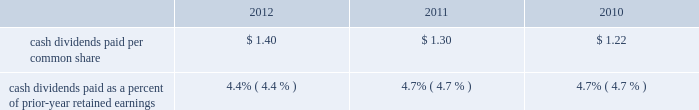And machine tooling to enhance manufacturing operations , and ongoing replacements of manufacturing and distribution equipment .
Capital spending in all three years also included spending for the replacement and enhancement of the company 2019s global enterprise resource planning ( erp ) management information systems , as well as spending to enhance the company 2019s corporate headquarters and research and development facilities in kenosha , wisconsin .
Snap-on believes that its cash generated from operations , as well as its available cash on hand and funds available from its credit facilities will be sufficient to fund the company 2019s capital expenditure requirements in 2013 .
In 2010 , snap-on acquired the remaining 40% ( 40 % ) interest in snap-on asia manufacturing ( zhejiang ) co. , ltd. , the company 2019s tool manufacturing operation in xiaoshan , china , for a purchase price of $ 7.7 million and $ 0.1 million of transaction costs ; snap-on acquired the initial 60% ( 60 % ) interest in 2008 .
See note 2 to the consolidated financial statements for additional information .
Financing activities net cash used by financing activities was $ 127.0 million in 2012 .
Net cash used by financing activities of $ 293.7 million in 2011 included the august 2011 repayment of $ 200 million of unsecured 6.25% ( 6.25 % ) notes upon maturity with available cash .
In december 2010 , snap-on sold $ 250 million of unsecured 4.25% ( 4.25 % ) long-term notes at a discount ; snap-on is using , and has used , the $ 247.7 million of proceeds from the sale of these notes , net of $ 1.6 million of transaction costs , for general corporate purposes , which included working capital , capital expenditures , repayment of all or a portion of the company 2019s $ 200 million , 6.25% ( 6.25 % ) unsecured notes that matured in august 2011 , and the financing of finance and contract receivables , primarily related to soc .
In january 2010 , snap-on repaid $ 150 million of unsecured floating rate debt upon maturity with available cash .
Proceeds from stock purchase and option plan exercises totaled $ 46.8 million in 2012 , $ 25.7 million in 2011 and $ 23.7 million in 2010 .
Snap-on has undertaken stock repurchases from time to time to offset dilution created by shares issued for employee and franchisee stock purchase plans , stock options and other corporate purposes .
In 2012 , snap-on repurchased 1180000 shares of its common stock for $ 78.1 million under its previously announced share repurchase programs .
As of 2012 year end , snap-on had remaining availability to repurchase up to an additional $ 180.9 million in common stock pursuant to its board of directors 2019 ( the 201cboard 201d ) authorizations .
The purchase of snap-on common stock is at the company 2019s discretion , subject to prevailing financial and market conditions .
Snap-on repurchased 628000 shares of its common stock for $ 37.4 million in 2011 ; snap-on repurchased 152000 shares of its common stock for $ 8.7 million in 2010 .
Snap-on believes that its cash generated from operations , available cash on hand , and funds available from its credit facilities , will be sufficient to fund the company 2019s share repurchases , if any , in 2013 .
Snap-on has paid consecutive quarterly cash dividends , without interruption or reduction , since 1939 .
Cash dividends paid in 2012 , 2011 and 2010 totaled $ 81.5 million , $ 76.7 million and $ 71.3 million , respectively .
On november 1 , 2012 , the company announced that its board increased the quarterly cash dividend by 11.8% ( 11.8 % ) to $ 0.38 per share ( $ 1.52 per share per year ) .
Quarterly dividends declared in 2012 were $ 0.38 per share in the fourth quarter and $ 0.34 per share in the first three quarters ( $ 1.40 per share for the year ) .
Quarterly dividends in 2011 were $ 0.34 per share in the fourth quarter and $ 0.32 per share in the first three quarters ( $ 1.30 per share for the year ) .
Quarterly dividends in 2010 were $ 0.32 per share in the fourth quarter and $ 0.30 per share in the first three quarters ( $ 1.22 per share for the year ) . .
Cash dividends paid as a percent of prior-year retained earnings 4.4% ( 4.4 % ) 4.7% ( 4.7 % ) snap-on believes that its cash generated from operations , available cash on hand and funds available from its credit facilities will be sufficient to pay dividends in 2013 .
Off-balance-sheet arrangements except as included below in the section labeled 201ccontractual obligations and commitments 201d and note 15 to the consolidated financial statements , the company had no off-balance-sheet arrangements as of 2012 year end .
2012 annual report 47 .
What is the average repurchase price per share in 2011? 
Computations: ((37.4 - 1000000) / 628000)
Answer: -1.5923. And machine tooling to enhance manufacturing operations , and ongoing replacements of manufacturing and distribution equipment .
Capital spending in all three years also included spending for the replacement and enhancement of the company 2019s global enterprise resource planning ( erp ) management information systems , as well as spending to enhance the company 2019s corporate headquarters and research and development facilities in kenosha , wisconsin .
Snap-on believes that its cash generated from operations , as well as its available cash on hand and funds available from its credit facilities will be sufficient to fund the company 2019s capital expenditure requirements in 2013 .
In 2010 , snap-on acquired the remaining 40% ( 40 % ) interest in snap-on asia manufacturing ( zhejiang ) co. , ltd. , the company 2019s tool manufacturing operation in xiaoshan , china , for a purchase price of $ 7.7 million and $ 0.1 million of transaction costs ; snap-on acquired the initial 60% ( 60 % ) interest in 2008 .
See note 2 to the consolidated financial statements for additional information .
Financing activities net cash used by financing activities was $ 127.0 million in 2012 .
Net cash used by financing activities of $ 293.7 million in 2011 included the august 2011 repayment of $ 200 million of unsecured 6.25% ( 6.25 % ) notes upon maturity with available cash .
In december 2010 , snap-on sold $ 250 million of unsecured 4.25% ( 4.25 % ) long-term notes at a discount ; snap-on is using , and has used , the $ 247.7 million of proceeds from the sale of these notes , net of $ 1.6 million of transaction costs , for general corporate purposes , which included working capital , capital expenditures , repayment of all or a portion of the company 2019s $ 200 million , 6.25% ( 6.25 % ) unsecured notes that matured in august 2011 , and the financing of finance and contract receivables , primarily related to soc .
In january 2010 , snap-on repaid $ 150 million of unsecured floating rate debt upon maturity with available cash .
Proceeds from stock purchase and option plan exercises totaled $ 46.8 million in 2012 , $ 25.7 million in 2011 and $ 23.7 million in 2010 .
Snap-on has undertaken stock repurchases from time to time to offset dilution created by shares issued for employee and franchisee stock purchase plans , stock options and other corporate purposes .
In 2012 , snap-on repurchased 1180000 shares of its common stock for $ 78.1 million under its previously announced share repurchase programs .
As of 2012 year end , snap-on had remaining availability to repurchase up to an additional $ 180.9 million in common stock pursuant to its board of directors 2019 ( the 201cboard 201d ) authorizations .
The purchase of snap-on common stock is at the company 2019s discretion , subject to prevailing financial and market conditions .
Snap-on repurchased 628000 shares of its common stock for $ 37.4 million in 2011 ; snap-on repurchased 152000 shares of its common stock for $ 8.7 million in 2010 .
Snap-on believes that its cash generated from operations , available cash on hand , and funds available from its credit facilities , will be sufficient to fund the company 2019s share repurchases , if any , in 2013 .
Snap-on has paid consecutive quarterly cash dividends , without interruption or reduction , since 1939 .
Cash dividends paid in 2012 , 2011 and 2010 totaled $ 81.5 million , $ 76.7 million and $ 71.3 million , respectively .
On november 1 , 2012 , the company announced that its board increased the quarterly cash dividend by 11.8% ( 11.8 % ) to $ 0.38 per share ( $ 1.52 per share per year ) .
Quarterly dividends declared in 2012 were $ 0.38 per share in the fourth quarter and $ 0.34 per share in the first three quarters ( $ 1.40 per share for the year ) .
Quarterly dividends in 2011 were $ 0.34 per share in the fourth quarter and $ 0.32 per share in the first three quarters ( $ 1.30 per share for the year ) .
Quarterly dividends in 2010 were $ 0.32 per share in the fourth quarter and $ 0.30 per share in the first three quarters ( $ 1.22 per share for the year ) . .
Cash dividends paid as a percent of prior-year retained earnings 4.4% ( 4.4 % ) 4.7% ( 4.7 % ) snap-on believes that its cash generated from operations , available cash on hand and funds available from its credit facilities will be sufficient to pay dividends in 2013 .
Off-balance-sheet arrangements except as included below in the section labeled 201ccontractual obligations and commitments 201d and note 15 to the consolidated financial statements , the company had no off-balance-sheet arrangements as of 2012 year end .
2012 annual report 47 .
What was the ratio of the snap-on share repurchase in 2011 compared to 2010? 
Computations: (628000 / 152000)
Answer: 4.13158. 